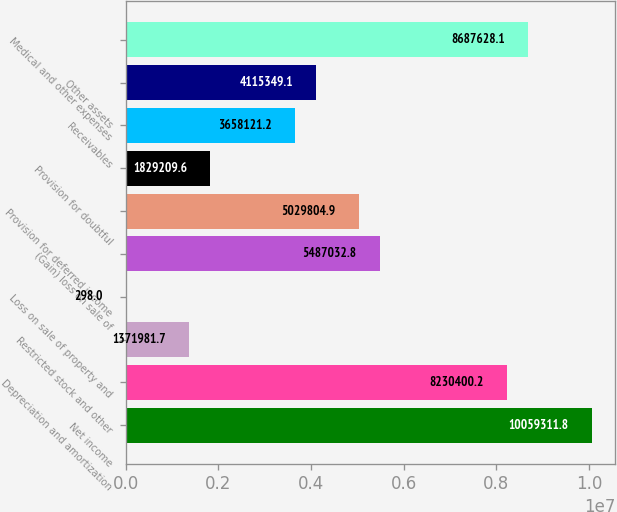<chart> <loc_0><loc_0><loc_500><loc_500><bar_chart><fcel>Net income<fcel>Depreciation and amortization<fcel>Restricted stock and other<fcel>Loss on sale of property and<fcel>(Gain) loss on sale of<fcel>Provision for deferred income<fcel>Provision for doubtful<fcel>Receivables<fcel>Other assets<fcel>Medical and other expenses<nl><fcel>1.00593e+07<fcel>8.2304e+06<fcel>1.37198e+06<fcel>298<fcel>5.48703e+06<fcel>5.0298e+06<fcel>1.82921e+06<fcel>3.65812e+06<fcel>4.11535e+06<fcel>8.68763e+06<nl></chart> 